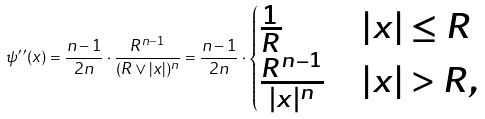Convert formula to latex. <formula><loc_0><loc_0><loc_500><loc_500>\psi ^ { \prime \prime } ( x ) = \frac { n - 1 } { 2 n } \cdot \frac { R ^ { n - 1 } } { ( R \vee | x | ) ^ { n } } = \frac { n - 1 } { 2 n } \cdot \begin{cases} \frac { 1 } { R } & | x | \leq R \\ \frac { R ^ { n - 1 } } { | x | ^ { n } } & | x | > R , \end{cases}</formula> 